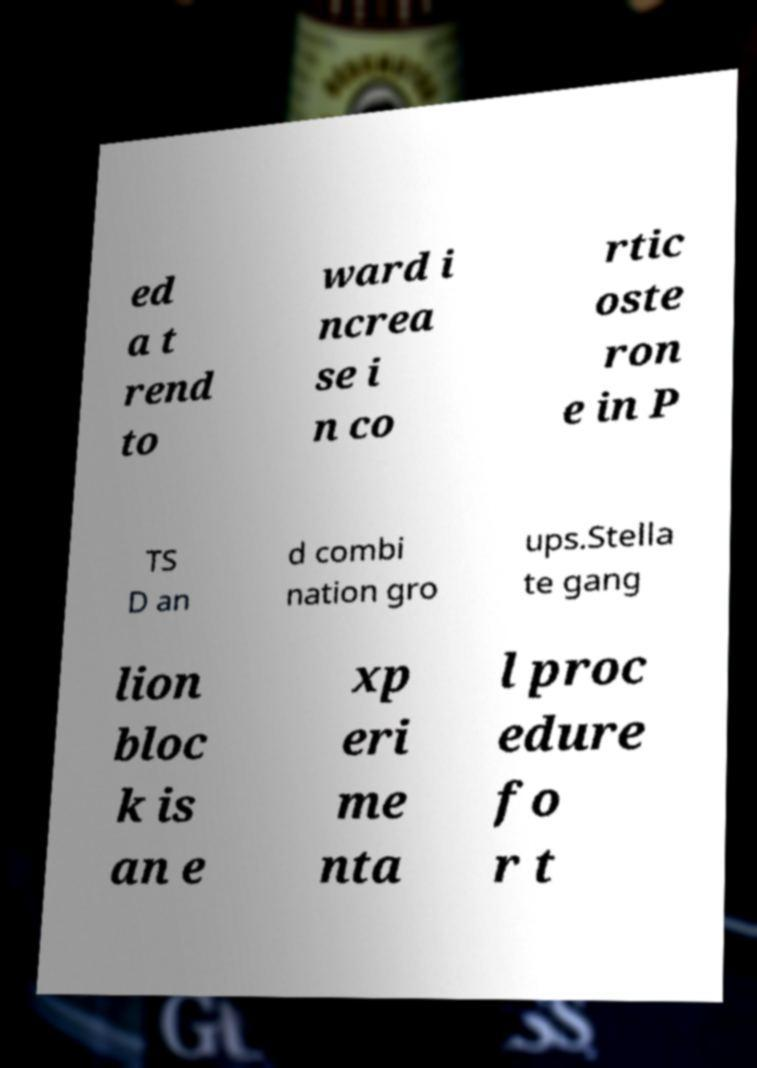Can you read and provide the text displayed in the image?This photo seems to have some interesting text. Can you extract and type it out for me? ed a t rend to ward i ncrea se i n co rtic oste ron e in P TS D an d combi nation gro ups.Stella te gang lion bloc k is an e xp eri me nta l proc edure fo r t 